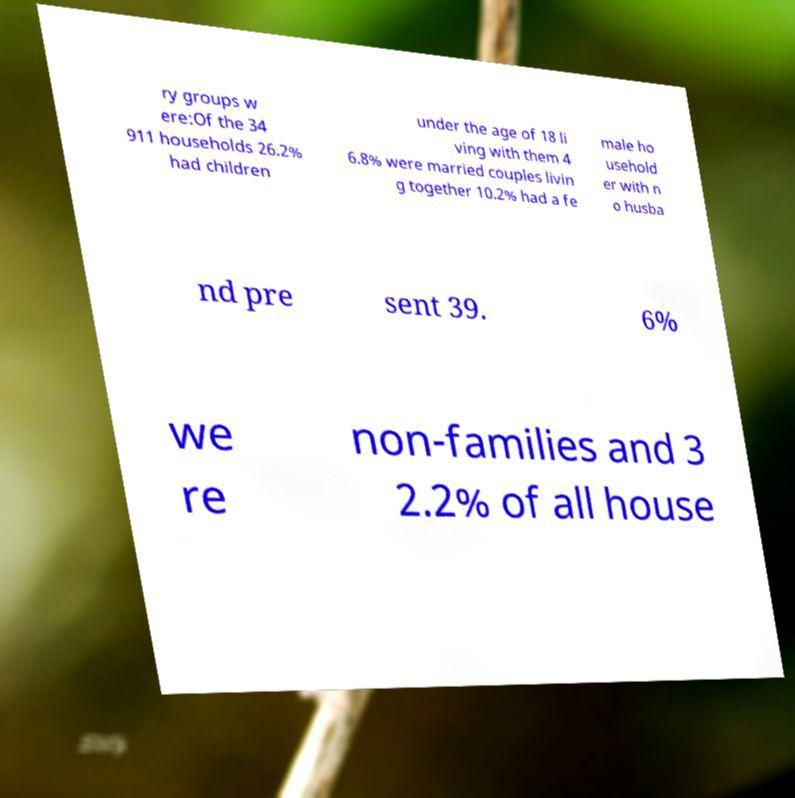I need the written content from this picture converted into text. Can you do that? ry groups w ere:Of the 34 911 households 26.2% had children under the age of 18 li ving with them 4 6.8% were married couples livin g together 10.2% had a fe male ho usehold er with n o husba nd pre sent 39. 6% we re non-families and 3 2.2% of all house 